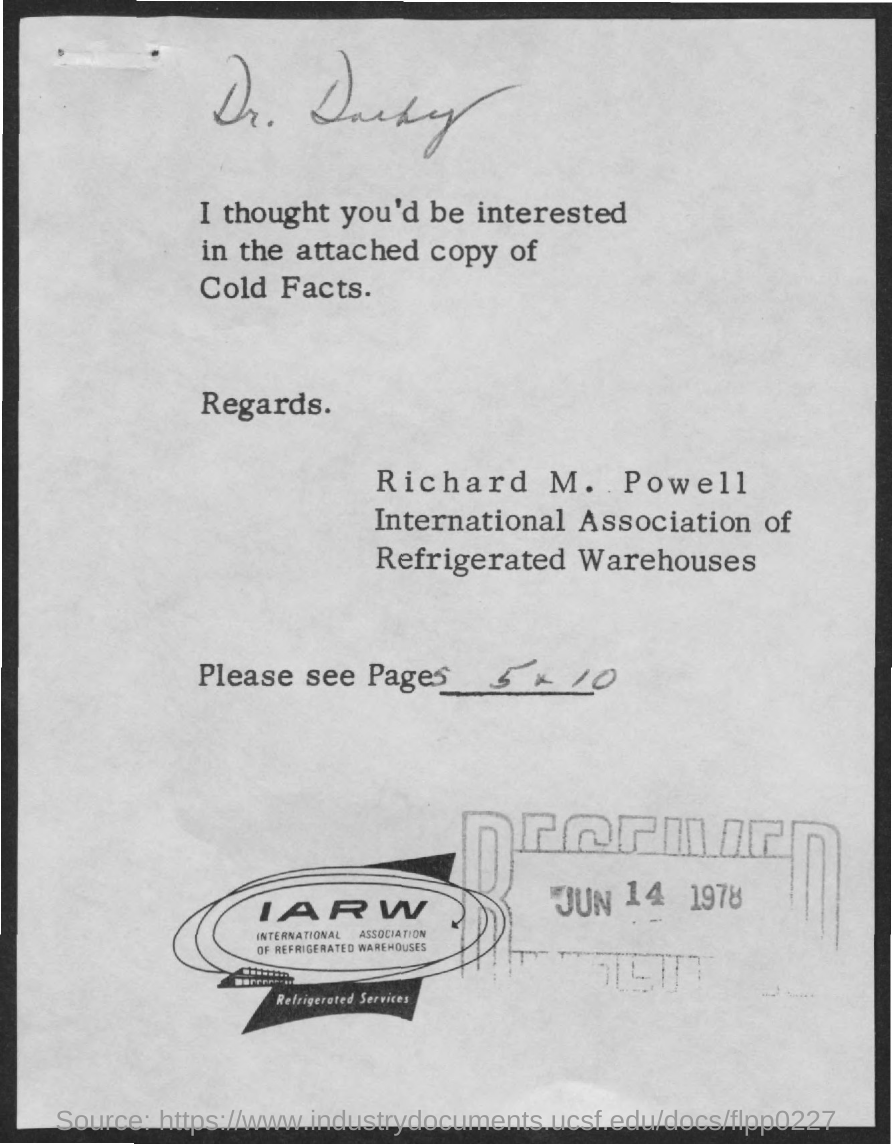Point out several critical features in this image. The full form of IARW is the International Association of Refrigerated Warehouses. The received date mentioned is JUN 14 1978. 